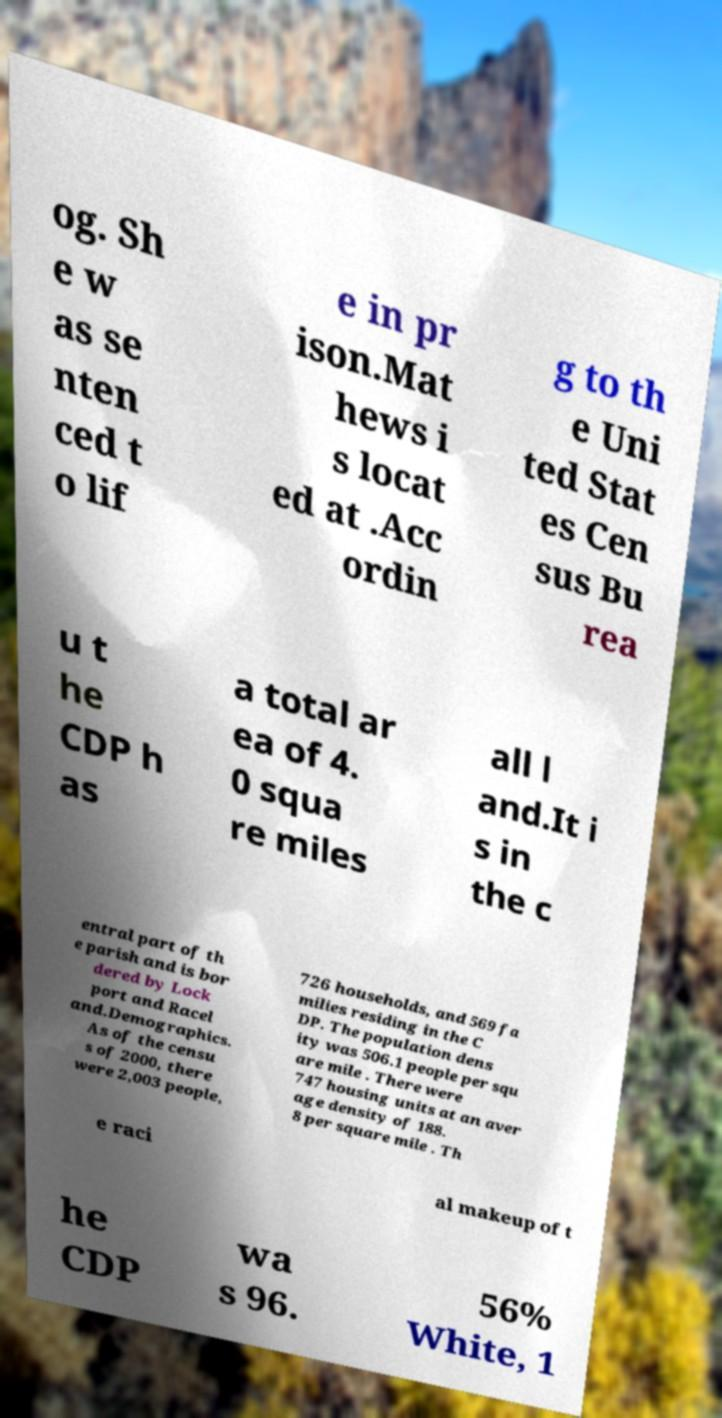For documentation purposes, I need the text within this image transcribed. Could you provide that? og. Sh e w as se nten ced t o lif e in pr ison.Mat hews i s locat ed at .Acc ordin g to th e Uni ted Stat es Cen sus Bu rea u t he CDP h as a total ar ea of 4. 0 squa re miles all l and.It i s in the c entral part of th e parish and is bor dered by Lock port and Racel and.Demographics. As of the censu s of 2000, there were 2,003 people, 726 households, and 569 fa milies residing in the C DP. The population dens ity was 506.1 people per squ are mile . There were 747 housing units at an aver age density of 188. 8 per square mile . Th e raci al makeup of t he CDP wa s 96. 56% White, 1 